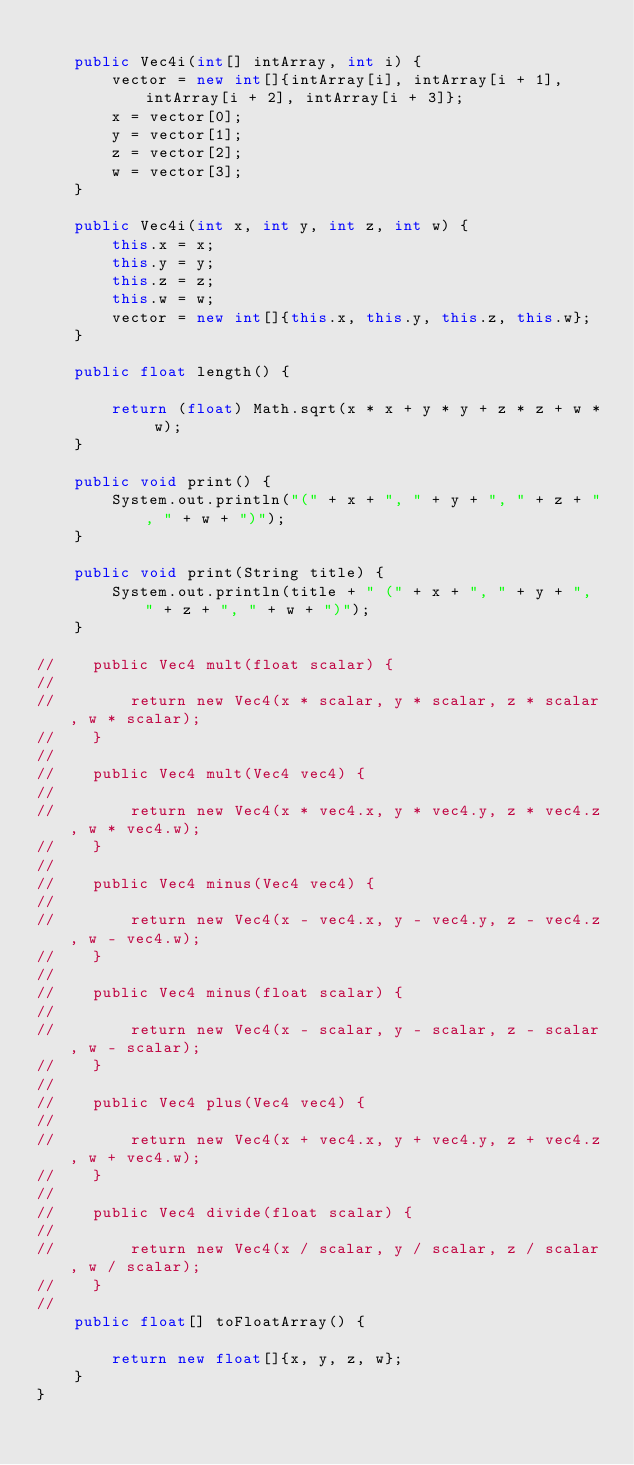Convert code to text. <code><loc_0><loc_0><loc_500><loc_500><_Java_>
    public Vec4i(int[] intArray, int i) {
        vector = new int[]{intArray[i], intArray[i + 1], intArray[i + 2], intArray[i + 3]};
        x = vector[0];
        y = vector[1];
        z = vector[2];
        w = vector[3];
    }

    public Vec4i(int x, int y, int z, int w) {
        this.x = x;
        this.y = y;
        this.z = z;
        this.w = w;
        vector = new int[]{this.x, this.y, this.z, this.w};
    }

    public float length() {

        return (float) Math.sqrt(x * x + y * y + z * z + w * w);
    }

    public void print() {
        System.out.println("(" + x + ", " + y + ", " + z + ", " + w + ")");
    }

    public void print(String title) {
        System.out.println(title + " (" + x + ", " + y + ", " + z + ", " + w + ")");
    }

//    public Vec4 mult(float scalar) {
//
//        return new Vec4(x * scalar, y * scalar, z * scalar, w * scalar);
//    }
//
//    public Vec4 mult(Vec4 vec4) {
//
//        return new Vec4(x * vec4.x, y * vec4.y, z * vec4.z, w * vec4.w);
//    }
//
//    public Vec4 minus(Vec4 vec4) {
//
//        return new Vec4(x - vec4.x, y - vec4.y, z - vec4.z, w - vec4.w);
//    }
//
//    public Vec4 minus(float scalar) {
//
//        return new Vec4(x - scalar, y - scalar, z - scalar, w - scalar);
//    }
//
//    public Vec4 plus(Vec4 vec4) {
//
//        return new Vec4(x + vec4.x, y + vec4.y, z + vec4.z, w + vec4.w);
//    }
//
//    public Vec4 divide(float scalar) {
//
//        return new Vec4(x / scalar, y / scalar, z / scalar, w / scalar);
//    }
//
    public float[] toFloatArray() {

        return new float[]{x, y, z, w};
    }
}
</code> 